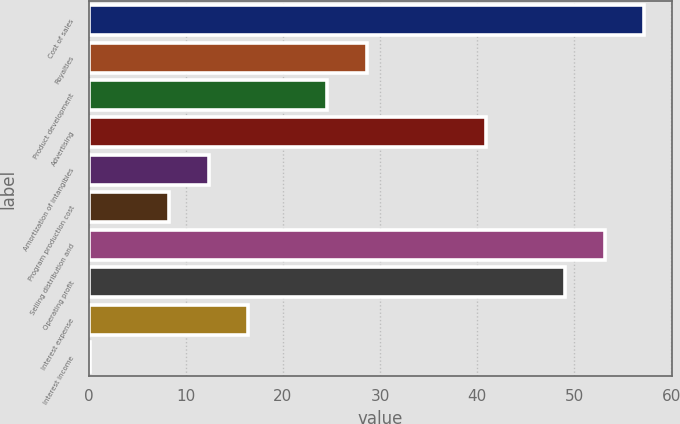Convert chart. <chart><loc_0><loc_0><loc_500><loc_500><bar_chart><fcel>Cost of sales<fcel>Royalties<fcel>Product development<fcel>Advertising<fcel>Amortization of intangibles<fcel>Program production cost<fcel>Selling distribution and<fcel>Operating profit<fcel>Interest expense<fcel>Interest income<nl><fcel>57.22<fcel>28.66<fcel>24.58<fcel>40.9<fcel>12.34<fcel>8.26<fcel>53.14<fcel>49.06<fcel>16.42<fcel>0.1<nl></chart> 